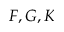<formula> <loc_0><loc_0><loc_500><loc_500>F , G , K</formula> 